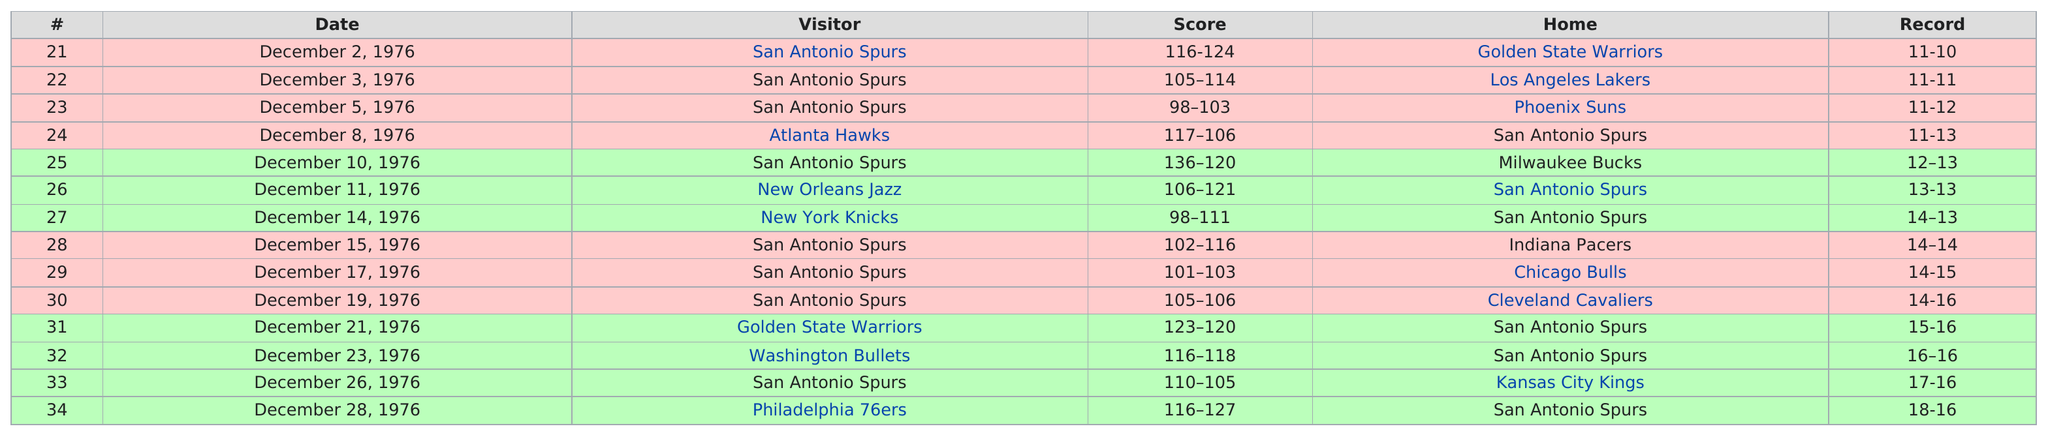Indicate a few pertinent items in this graphic. The Atlanta Hawks won consecutively 1 time. There are a total of 14 games listed. In how many games did one of the teams score below 100 points? The answer is 2. The San Antonio Spurs won in the game where the highest number of points was scored. In December of 1976, the San Antonio Spurs were at home a total of six times. 